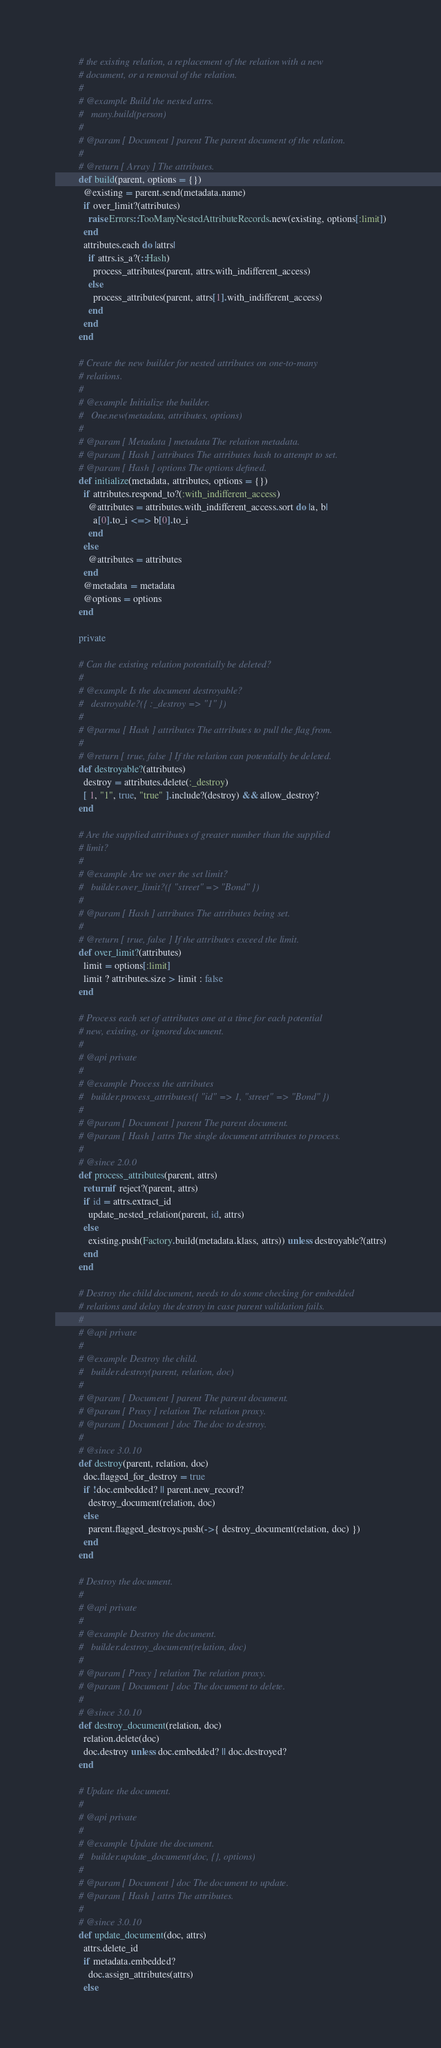Convert code to text. <code><loc_0><loc_0><loc_500><loc_500><_Ruby_>          # the existing relation, a replacement of the relation with a new
          # document, or a removal of the relation.
          #
          # @example Build the nested attrs.
          #   many.build(person)
          #
          # @param [ Document ] parent The parent document of the relation.
          #
          # @return [ Array ] The attributes.
          def build(parent, options = {})
            @existing = parent.send(metadata.name)
            if over_limit?(attributes)
              raise Errors::TooManyNestedAttributeRecords.new(existing, options[:limit])
            end
            attributes.each do |attrs|
              if attrs.is_a?(::Hash)
                process_attributes(parent, attrs.with_indifferent_access)
              else
                process_attributes(parent, attrs[1].with_indifferent_access)
              end
            end
          end

          # Create the new builder for nested attributes on one-to-many
          # relations.
          #
          # @example Initialize the builder.
          #   One.new(metadata, attributes, options)
          #
          # @param [ Metadata ] metadata The relation metadata.
          # @param [ Hash ] attributes The attributes hash to attempt to set.
          # @param [ Hash ] options The options defined.
          def initialize(metadata, attributes, options = {})
            if attributes.respond_to?(:with_indifferent_access)
              @attributes = attributes.with_indifferent_access.sort do |a, b|
                a[0].to_i <=> b[0].to_i
              end
            else
              @attributes = attributes
            end
            @metadata = metadata
            @options = options
          end

          private

          # Can the existing relation potentially be deleted?
          #
          # @example Is the document destroyable?
          #   destroyable?({ :_destroy => "1" })
          #
          # @parma [ Hash ] attributes The attributes to pull the flag from.
          #
          # @return [ true, false ] If the relation can potentially be deleted.
          def destroyable?(attributes)
            destroy = attributes.delete(:_destroy)
            [ 1, "1", true, "true" ].include?(destroy) && allow_destroy?
          end

          # Are the supplied attributes of greater number than the supplied
          # limit?
          #
          # @example Are we over the set limit?
          #   builder.over_limit?({ "street" => "Bond" })
          #
          # @param [ Hash ] attributes The attributes being set.
          #
          # @return [ true, false ] If the attributes exceed the limit.
          def over_limit?(attributes)
            limit = options[:limit]
            limit ? attributes.size > limit : false
          end

          # Process each set of attributes one at a time for each potential
          # new, existing, or ignored document.
          #
          # @api private
          #
          # @example Process the attributes
          #   builder.process_attributes({ "id" => 1, "street" => "Bond" })
          #
          # @param [ Document ] parent The parent document.
          # @param [ Hash ] attrs The single document attributes to process.
          #
          # @since 2.0.0
          def process_attributes(parent, attrs)
            return if reject?(parent, attrs)
            if id = attrs.extract_id
              update_nested_relation(parent, id, attrs)
            else
              existing.push(Factory.build(metadata.klass, attrs)) unless destroyable?(attrs)
            end
          end

          # Destroy the child document, needs to do some checking for embedded
          # relations and delay the destroy in case parent validation fails.
          #
          # @api private
          #
          # @example Destroy the child.
          #   builder.destroy(parent, relation, doc)
          #
          # @param [ Document ] parent The parent document.
          # @param [ Proxy ] relation The relation proxy.
          # @param [ Document ] doc The doc to destroy.
          #
          # @since 3.0.10
          def destroy(parent, relation, doc)
            doc.flagged_for_destroy = true
            if !doc.embedded? || parent.new_record?
              destroy_document(relation, doc)
            else
              parent.flagged_destroys.push(->{ destroy_document(relation, doc) })
            end
          end

          # Destroy the document.
          #
          # @api private
          #
          # @example Destroy the document.
          #   builder.destroy_document(relation, doc)
          #
          # @param [ Proxy ] relation The relation proxy.
          # @param [ Document ] doc The document to delete.
          #
          # @since 3.0.10
          def destroy_document(relation, doc)
            relation.delete(doc)
            doc.destroy unless doc.embedded? || doc.destroyed?
          end

          # Update the document.
          #
          # @api private
          #
          # @example Update the document.
          #   builder.update_document(doc, {}, options)
          #
          # @param [ Document ] doc The document to update.
          # @param [ Hash ] attrs The attributes.
          #
          # @since 3.0.10
          def update_document(doc, attrs)
            attrs.delete_id
            if metadata.embedded?
              doc.assign_attributes(attrs)
            else</code> 